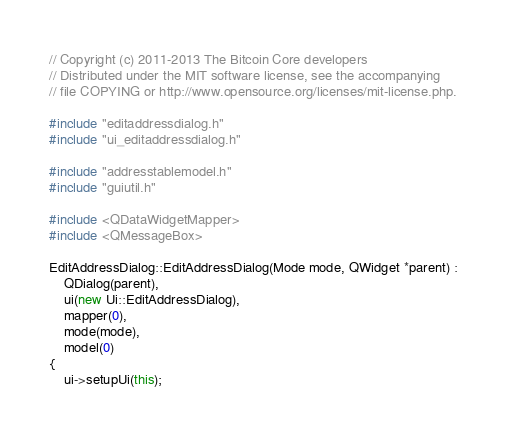Convert code to text. <code><loc_0><loc_0><loc_500><loc_500><_C++_>// Copyright (c) 2011-2013 The Bitcoin Core developers
// Distributed under the MIT software license, see the accompanying
// file COPYING or http://www.opensource.org/licenses/mit-license.php.

#include "editaddressdialog.h"
#include "ui_editaddressdialog.h"

#include "addresstablemodel.h"
#include "guiutil.h"

#include <QDataWidgetMapper>
#include <QMessageBox>

EditAddressDialog::EditAddressDialog(Mode mode, QWidget *parent) :
    QDialog(parent),
    ui(new Ui::EditAddressDialog),
    mapper(0),
    mode(mode),
    model(0)
{
    ui->setupUi(this);
</code> 